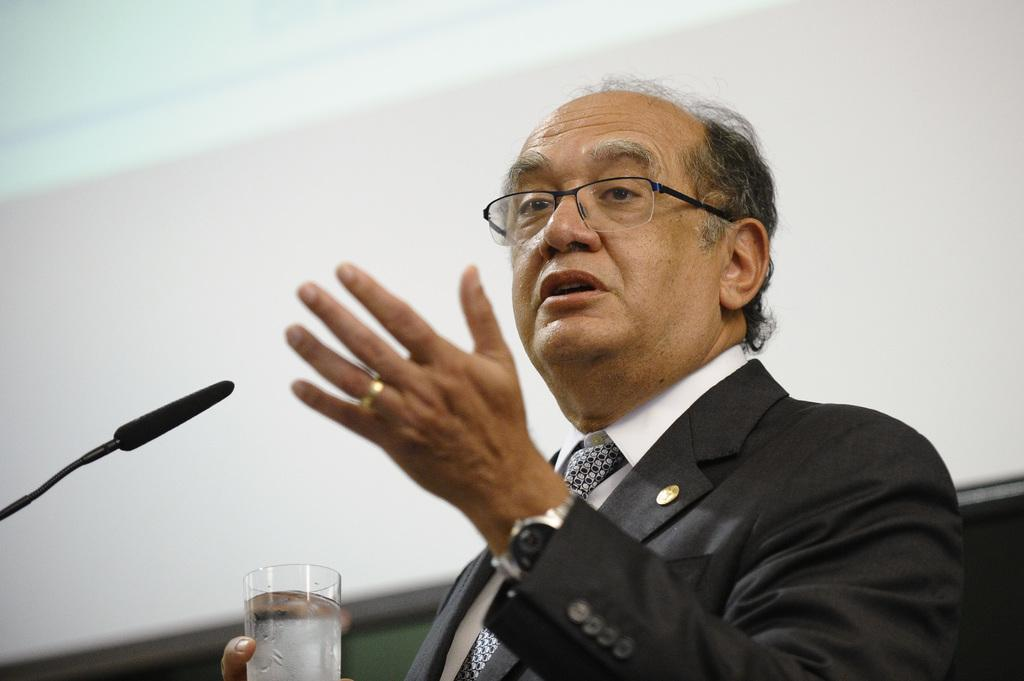What is the person in the image doing? The person is standing and talking in the image. What object is the person holding? The person is holding a glass in the image. What can be seen on the left side of the image? There is a microphone on the left side of the image. What color is the wall in the background of the image? The wall in the background of the image is painted white. Can you tell me what type of art is displayed on the receipt in the image? There is no receipt present in the image, and therefore no art can be observed on it. 